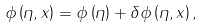<formula> <loc_0><loc_0><loc_500><loc_500>\phi \left ( \eta , x \right ) = \phi \left ( \eta \right ) + \delta \phi \left ( \eta , x \right ) ,</formula> 